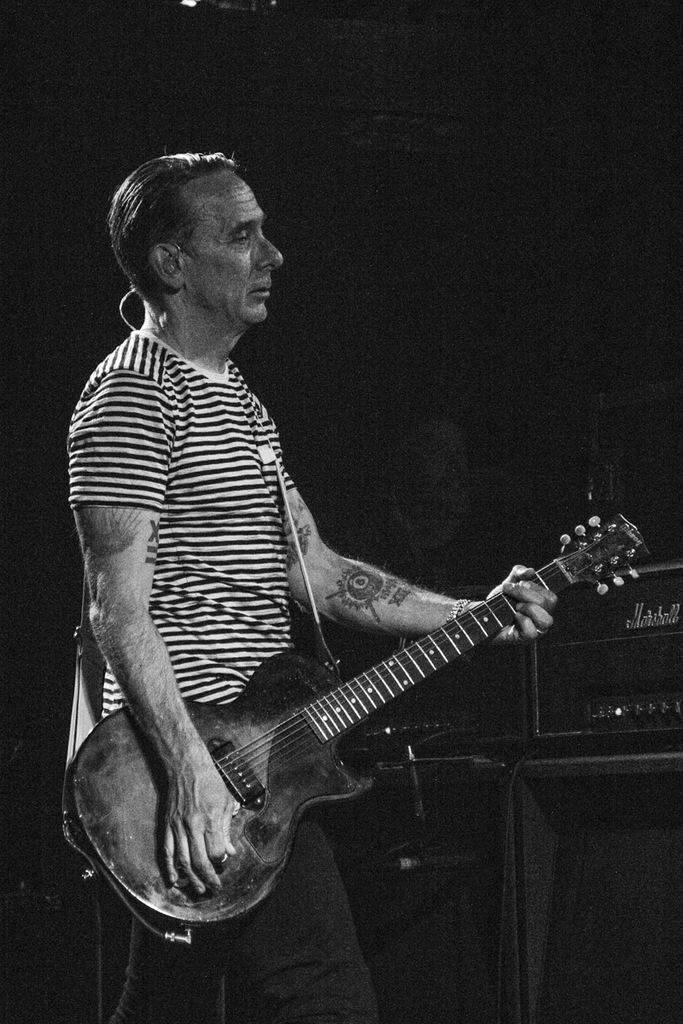What is the man in the image doing? The man is playing the guitar. What object is the man holding in the image? The man is holding a guitar. Can you describe the background of the image? There is a speaker in the background of the image, and it is black in color. What type of plantation can be seen in the image? There is no plantation present in the image. What sky-related theory is being demonstrated in the image? There is no sky-related theory being demonstrated in the image. 